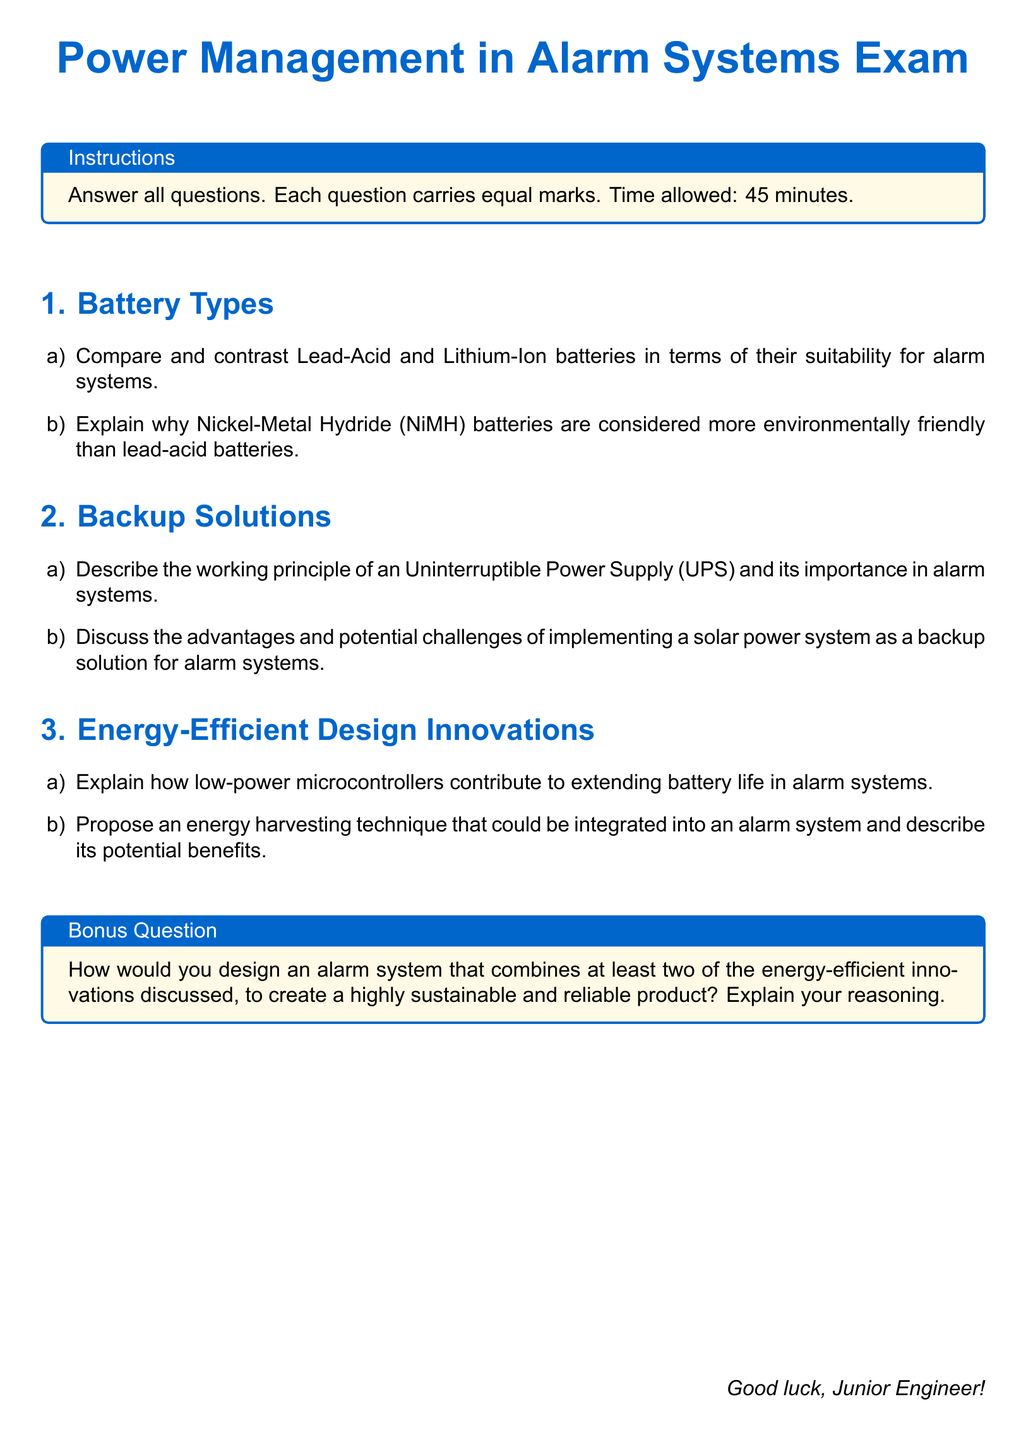What is the total number of sections in the exam? The exam consists of three main sections: Battery Types, Backup Solutions, and Energy-Efficient Design Innovations.
Answer: 3 What color is used for the main text? The main text color defined in the document is specified as RGB(0,102,204).
Answer: maincolor What is the total allowed time for the exam? The instructions in the document state that the time allowed to complete the exam is 45 minutes.
Answer: 45 minutes What are the two batteries compared in the first question under Battery Types? The first question asks to compare Lead-Acid and Lithium-Ion batteries.
Answer: Lead-Acid and Lithium-Ion What is the bonus question asking for? The bonus question prompts the design of an alarm system combining at least two energy-efficient innovations.
Answer: Design an alarm system combining energy-efficient innovations What is the designated title for the instructions box? The instructions box title is provided in the document as "Instructions".
Answer: Instructions Which type of battery is highlighted for its environmental friendliness in the document? The document highlights Nickel-Metal Hydride (NiMH) batteries for their environmental benefits.
Answer: Nickel-Metal Hydride (NiMH) How many advantages are discussed for implementing solar power as a backup solution? The document prompts a discussion on advantages and potential challenges, implying at least two aspects should be considered.
Answer: At least two Which specific design innovation contributes to extending battery life? The document identifies low-power microcontrollers as a crucial design innovation for battery life extension.
Answer: Low-power microcontrollers 